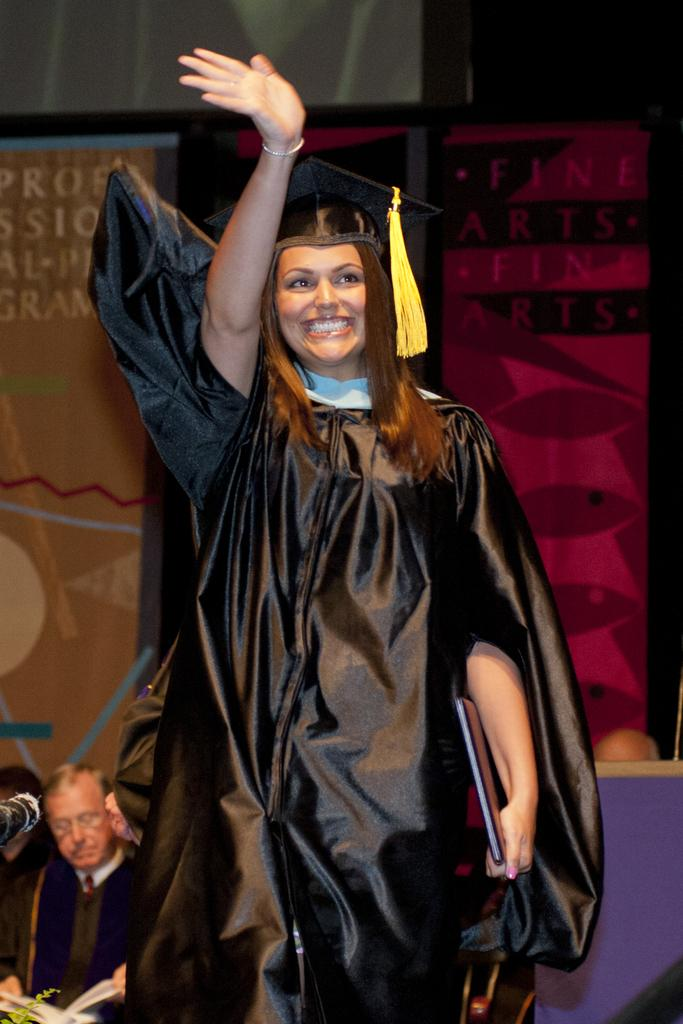What is present in the image? There is a person and an object in the image. Can you describe the background of the image? There is a name board and other objects in the background of the image. What disease is the person in the image suffering from? There is no indication of any disease in the image, and we cannot make assumptions about the person's health. What class is the person in the image attending? There is no indication of a class or educational setting in the image. 